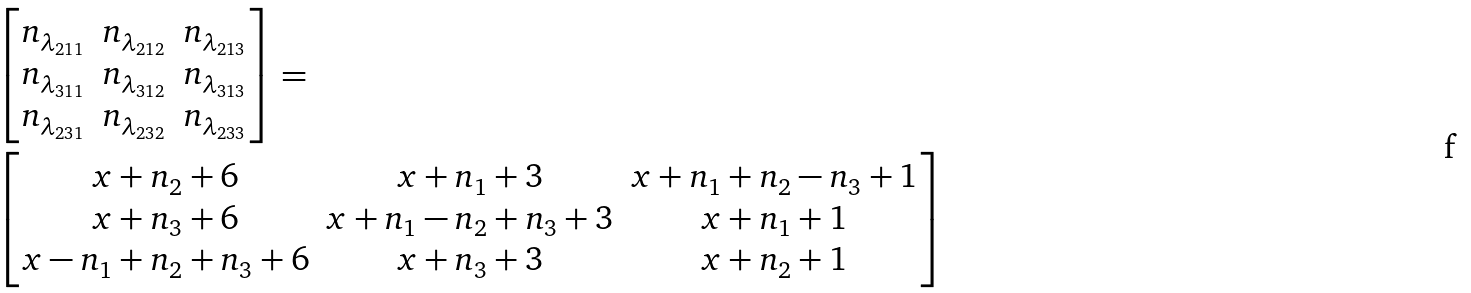Convert formula to latex. <formula><loc_0><loc_0><loc_500><loc_500>& \begin{bmatrix} n _ { \lambda _ { 2 1 1 } } & n _ { \lambda _ { 2 1 2 } } & n _ { \lambda _ { 2 1 3 } } \\ n _ { \lambda _ { 3 1 1 } } & n _ { \lambda _ { 3 1 2 } } & n _ { \lambda _ { 3 1 3 } } \\ n _ { \lambda _ { 2 3 1 } } & n _ { \lambda _ { 2 3 2 } } & n _ { \lambda _ { 2 3 3 } } \\ \end{bmatrix} = \\ & \begin{bmatrix} { x + n _ { 2 } + 6 } & { x + n _ { 1 } + 3 } & { x + n _ { 1 } + n _ { 2 } - n _ { 3 } + 1 } \\ { x + n _ { 3 } + 6 } & { x + n _ { 1 } - n _ { 2 } + n _ { 3 } + 3 } & { x + n _ { 1 } + 1 } \\ { x - n _ { 1 } + n _ { 2 } + n _ { 3 } + 6 } & { x + n _ { 3 } + 3 } & { x + n _ { 2 } + 1 } \end{bmatrix}</formula> 